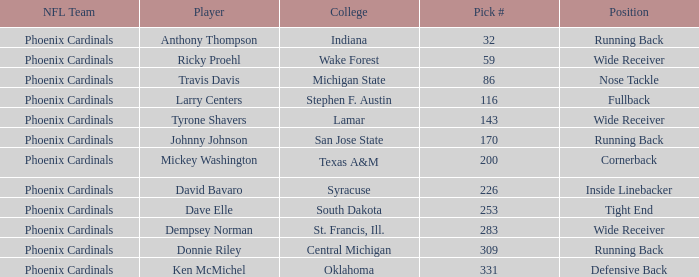Which player was a running back from San Jose State? Johnny Johnson. 